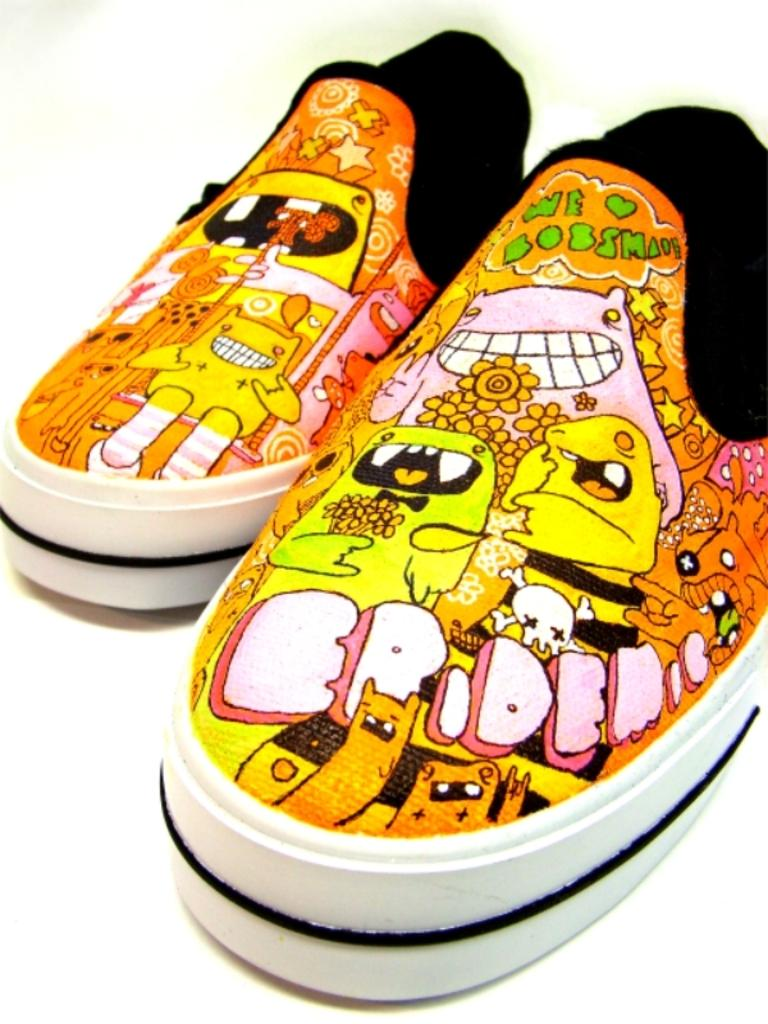What objects are present in the image? There are shoes in the image. Where are the shoes located? The shoes are on a platform. What type of waves can be seen in the image? There are no waves present in the image; it features shoes on a platform. Can you describe the cloud formation in the image? There is no cloud formation in the image, as it only contains shoes on a platform. 